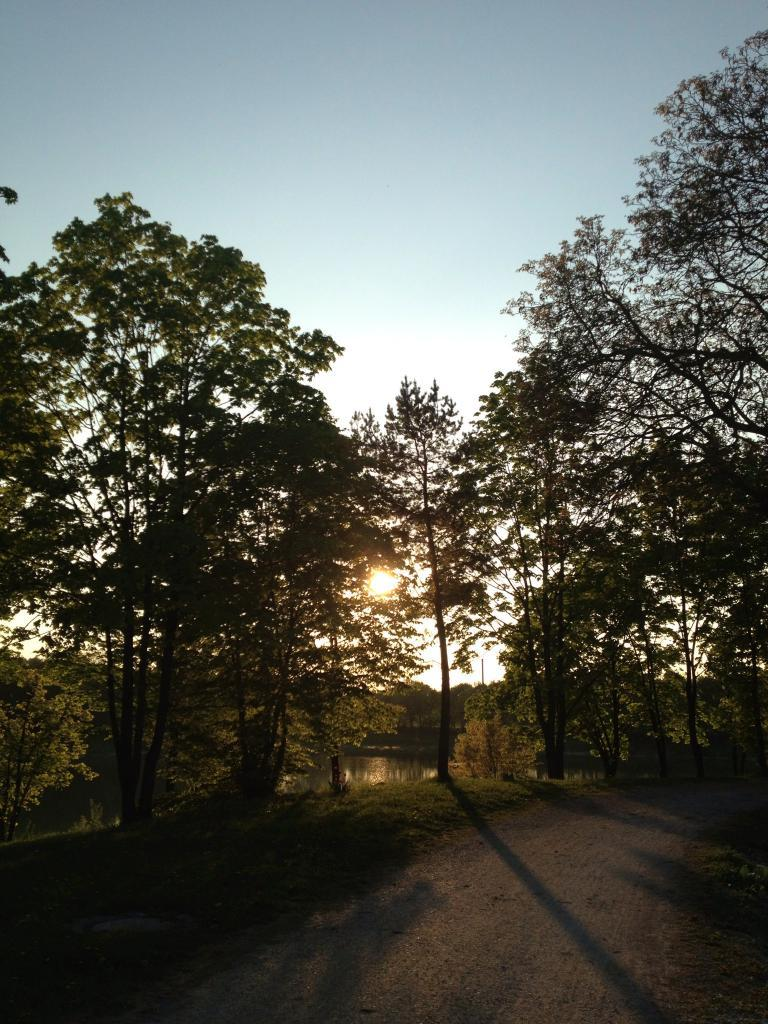What can be seen in the foreground of the image? There is a road and trees in the foreground of the image. What is visible in the background of the image? The sky is visible in the background of the image, and the sun is observable in the background. How many women can be seen holding the hot floor in the image? There are no women present in the image. 